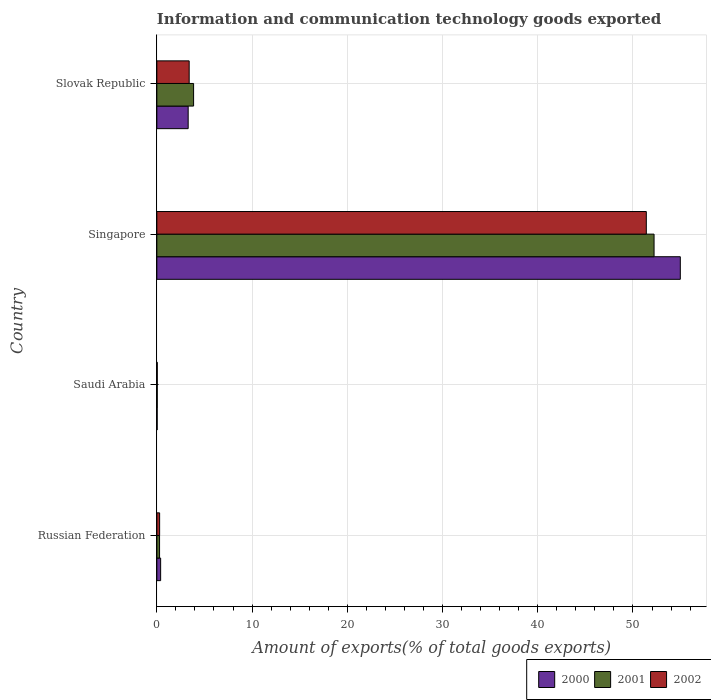How many groups of bars are there?
Give a very brief answer. 4. Are the number of bars per tick equal to the number of legend labels?
Offer a terse response. Yes. How many bars are there on the 1st tick from the top?
Your response must be concise. 3. How many bars are there on the 4th tick from the bottom?
Your response must be concise. 3. What is the label of the 1st group of bars from the top?
Give a very brief answer. Slovak Republic. In how many cases, is the number of bars for a given country not equal to the number of legend labels?
Offer a terse response. 0. What is the amount of goods exported in 2002 in Saudi Arabia?
Offer a terse response. 0.04. Across all countries, what is the maximum amount of goods exported in 2001?
Offer a very short reply. 52.22. Across all countries, what is the minimum amount of goods exported in 2001?
Keep it short and to the point. 0.04. In which country was the amount of goods exported in 2000 maximum?
Your answer should be compact. Singapore. In which country was the amount of goods exported in 2001 minimum?
Provide a short and direct response. Saudi Arabia. What is the total amount of goods exported in 2001 in the graph?
Offer a very short reply. 56.4. What is the difference between the amount of goods exported in 2001 in Russian Federation and that in Singapore?
Your answer should be very brief. -51.93. What is the difference between the amount of goods exported in 2001 in Slovak Republic and the amount of goods exported in 2002 in Singapore?
Give a very brief answer. -47.54. What is the average amount of goods exported in 2002 per country?
Ensure brevity in your answer.  13.78. What is the difference between the amount of goods exported in 2000 and amount of goods exported in 2002 in Slovak Republic?
Provide a short and direct response. -0.11. What is the ratio of the amount of goods exported in 2000 in Singapore to that in Slovak Republic?
Keep it short and to the point. 16.71. What is the difference between the highest and the second highest amount of goods exported in 2002?
Your response must be concise. 48.01. What is the difference between the highest and the lowest amount of goods exported in 2001?
Keep it short and to the point. 52.17. What does the 2nd bar from the top in Slovak Republic represents?
Offer a very short reply. 2001. What does the 2nd bar from the bottom in Saudi Arabia represents?
Give a very brief answer. 2001. Is it the case that in every country, the sum of the amount of goods exported in 2000 and amount of goods exported in 2002 is greater than the amount of goods exported in 2001?
Ensure brevity in your answer.  Yes. How many bars are there?
Keep it short and to the point. 12. Are all the bars in the graph horizontal?
Your answer should be compact. Yes. What is the difference between two consecutive major ticks on the X-axis?
Ensure brevity in your answer.  10. Does the graph contain any zero values?
Make the answer very short. No. Does the graph contain grids?
Make the answer very short. Yes. Where does the legend appear in the graph?
Make the answer very short. Bottom right. How many legend labels are there?
Offer a terse response. 3. What is the title of the graph?
Your answer should be very brief. Information and communication technology goods exported. What is the label or title of the X-axis?
Your answer should be very brief. Amount of exports(% of total goods exports). What is the label or title of the Y-axis?
Offer a very short reply. Country. What is the Amount of exports(% of total goods exports) in 2000 in Russian Federation?
Provide a succinct answer. 0.4. What is the Amount of exports(% of total goods exports) in 2001 in Russian Federation?
Your answer should be very brief. 0.28. What is the Amount of exports(% of total goods exports) of 2002 in Russian Federation?
Keep it short and to the point. 0.29. What is the Amount of exports(% of total goods exports) in 2000 in Saudi Arabia?
Provide a succinct answer. 0.03. What is the Amount of exports(% of total goods exports) in 2001 in Saudi Arabia?
Your response must be concise. 0.04. What is the Amount of exports(% of total goods exports) in 2002 in Saudi Arabia?
Give a very brief answer. 0.04. What is the Amount of exports(% of total goods exports) in 2000 in Singapore?
Keep it short and to the point. 54.97. What is the Amount of exports(% of total goods exports) in 2001 in Singapore?
Keep it short and to the point. 52.22. What is the Amount of exports(% of total goods exports) in 2002 in Singapore?
Ensure brevity in your answer.  51.4. What is the Amount of exports(% of total goods exports) in 2000 in Slovak Republic?
Your response must be concise. 3.29. What is the Amount of exports(% of total goods exports) of 2001 in Slovak Republic?
Provide a succinct answer. 3.86. What is the Amount of exports(% of total goods exports) in 2002 in Slovak Republic?
Provide a succinct answer. 3.4. Across all countries, what is the maximum Amount of exports(% of total goods exports) of 2000?
Offer a terse response. 54.97. Across all countries, what is the maximum Amount of exports(% of total goods exports) of 2001?
Provide a succinct answer. 52.22. Across all countries, what is the maximum Amount of exports(% of total goods exports) in 2002?
Your response must be concise. 51.4. Across all countries, what is the minimum Amount of exports(% of total goods exports) in 2000?
Offer a terse response. 0.03. Across all countries, what is the minimum Amount of exports(% of total goods exports) in 2001?
Your answer should be very brief. 0.04. Across all countries, what is the minimum Amount of exports(% of total goods exports) of 2002?
Keep it short and to the point. 0.04. What is the total Amount of exports(% of total goods exports) in 2000 in the graph?
Your response must be concise. 58.7. What is the total Amount of exports(% of total goods exports) in 2001 in the graph?
Your answer should be very brief. 56.4. What is the total Amount of exports(% of total goods exports) of 2002 in the graph?
Your answer should be very brief. 55.13. What is the difference between the Amount of exports(% of total goods exports) in 2000 in Russian Federation and that in Saudi Arabia?
Provide a succinct answer. 0.37. What is the difference between the Amount of exports(% of total goods exports) in 2001 in Russian Federation and that in Saudi Arabia?
Your response must be concise. 0.24. What is the difference between the Amount of exports(% of total goods exports) of 2002 in Russian Federation and that in Saudi Arabia?
Give a very brief answer. 0.25. What is the difference between the Amount of exports(% of total goods exports) in 2000 in Russian Federation and that in Singapore?
Make the answer very short. -54.58. What is the difference between the Amount of exports(% of total goods exports) of 2001 in Russian Federation and that in Singapore?
Keep it short and to the point. -51.93. What is the difference between the Amount of exports(% of total goods exports) in 2002 in Russian Federation and that in Singapore?
Offer a very short reply. -51.11. What is the difference between the Amount of exports(% of total goods exports) in 2000 in Russian Federation and that in Slovak Republic?
Your answer should be very brief. -2.89. What is the difference between the Amount of exports(% of total goods exports) of 2001 in Russian Federation and that in Slovak Republic?
Provide a short and direct response. -3.57. What is the difference between the Amount of exports(% of total goods exports) in 2002 in Russian Federation and that in Slovak Republic?
Offer a terse response. -3.1. What is the difference between the Amount of exports(% of total goods exports) in 2000 in Saudi Arabia and that in Singapore?
Provide a succinct answer. -54.94. What is the difference between the Amount of exports(% of total goods exports) in 2001 in Saudi Arabia and that in Singapore?
Your answer should be very brief. -52.17. What is the difference between the Amount of exports(% of total goods exports) in 2002 in Saudi Arabia and that in Singapore?
Your answer should be very brief. -51.36. What is the difference between the Amount of exports(% of total goods exports) of 2000 in Saudi Arabia and that in Slovak Republic?
Provide a short and direct response. -3.26. What is the difference between the Amount of exports(% of total goods exports) of 2001 in Saudi Arabia and that in Slovak Republic?
Offer a terse response. -3.82. What is the difference between the Amount of exports(% of total goods exports) in 2002 in Saudi Arabia and that in Slovak Republic?
Offer a very short reply. -3.35. What is the difference between the Amount of exports(% of total goods exports) in 2000 in Singapore and that in Slovak Republic?
Provide a succinct answer. 51.69. What is the difference between the Amount of exports(% of total goods exports) in 2001 in Singapore and that in Slovak Republic?
Your response must be concise. 48.36. What is the difference between the Amount of exports(% of total goods exports) of 2002 in Singapore and that in Slovak Republic?
Your response must be concise. 48.01. What is the difference between the Amount of exports(% of total goods exports) in 2000 in Russian Federation and the Amount of exports(% of total goods exports) in 2001 in Saudi Arabia?
Make the answer very short. 0.36. What is the difference between the Amount of exports(% of total goods exports) in 2000 in Russian Federation and the Amount of exports(% of total goods exports) in 2002 in Saudi Arabia?
Provide a succinct answer. 0.35. What is the difference between the Amount of exports(% of total goods exports) in 2001 in Russian Federation and the Amount of exports(% of total goods exports) in 2002 in Saudi Arabia?
Offer a very short reply. 0.24. What is the difference between the Amount of exports(% of total goods exports) in 2000 in Russian Federation and the Amount of exports(% of total goods exports) in 2001 in Singapore?
Offer a terse response. -51.82. What is the difference between the Amount of exports(% of total goods exports) in 2000 in Russian Federation and the Amount of exports(% of total goods exports) in 2002 in Singapore?
Keep it short and to the point. -51. What is the difference between the Amount of exports(% of total goods exports) of 2001 in Russian Federation and the Amount of exports(% of total goods exports) of 2002 in Singapore?
Your answer should be compact. -51.12. What is the difference between the Amount of exports(% of total goods exports) of 2000 in Russian Federation and the Amount of exports(% of total goods exports) of 2001 in Slovak Republic?
Your answer should be compact. -3.46. What is the difference between the Amount of exports(% of total goods exports) of 2000 in Russian Federation and the Amount of exports(% of total goods exports) of 2002 in Slovak Republic?
Keep it short and to the point. -3. What is the difference between the Amount of exports(% of total goods exports) of 2001 in Russian Federation and the Amount of exports(% of total goods exports) of 2002 in Slovak Republic?
Give a very brief answer. -3.11. What is the difference between the Amount of exports(% of total goods exports) in 2000 in Saudi Arabia and the Amount of exports(% of total goods exports) in 2001 in Singapore?
Your answer should be compact. -52.18. What is the difference between the Amount of exports(% of total goods exports) of 2000 in Saudi Arabia and the Amount of exports(% of total goods exports) of 2002 in Singapore?
Your answer should be very brief. -51.37. What is the difference between the Amount of exports(% of total goods exports) of 2001 in Saudi Arabia and the Amount of exports(% of total goods exports) of 2002 in Singapore?
Make the answer very short. -51.36. What is the difference between the Amount of exports(% of total goods exports) in 2000 in Saudi Arabia and the Amount of exports(% of total goods exports) in 2001 in Slovak Republic?
Ensure brevity in your answer.  -3.83. What is the difference between the Amount of exports(% of total goods exports) in 2000 in Saudi Arabia and the Amount of exports(% of total goods exports) in 2002 in Slovak Republic?
Ensure brevity in your answer.  -3.36. What is the difference between the Amount of exports(% of total goods exports) of 2001 in Saudi Arabia and the Amount of exports(% of total goods exports) of 2002 in Slovak Republic?
Offer a very short reply. -3.35. What is the difference between the Amount of exports(% of total goods exports) in 2000 in Singapore and the Amount of exports(% of total goods exports) in 2001 in Slovak Republic?
Provide a short and direct response. 51.12. What is the difference between the Amount of exports(% of total goods exports) in 2000 in Singapore and the Amount of exports(% of total goods exports) in 2002 in Slovak Republic?
Your response must be concise. 51.58. What is the difference between the Amount of exports(% of total goods exports) in 2001 in Singapore and the Amount of exports(% of total goods exports) in 2002 in Slovak Republic?
Your answer should be compact. 48.82. What is the average Amount of exports(% of total goods exports) of 2000 per country?
Give a very brief answer. 14.67. What is the average Amount of exports(% of total goods exports) of 2001 per country?
Provide a succinct answer. 14.1. What is the average Amount of exports(% of total goods exports) of 2002 per country?
Your response must be concise. 13.78. What is the difference between the Amount of exports(% of total goods exports) in 2000 and Amount of exports(% of total goods exports) in 2001 in Russian Federation?
Make the answer very short. 0.11. What is the difference between the Amount of exports(% of total goods exports) in 2000 and Amount of exports(% of total goods exports) in 2002 in Russian Federation?
Keep it short and to the point. 0.11. What is the difference between the Amount of exports(% of total goods exports) in 2001 and Amount of exports(% of total goods exports) in 2002 in Russian Federation?
Your response must be concise. -0.01. What is the difference between the Amount of exports(% of total goods exports) in 2000 and Amount of exports(% of total goods exports) in 2001 in Saudi Arabia?
Offer a terse response. -0.01. What is the difference between the Amount of exports(% of total goods exports) in 2000 and Amount of exports(% of total goods exports) in 2002 in Saudi Arabia?
Offer a terse response. -0.01. What is the difference between the Amount of exports(% of total goods exports) in 2001 and Amount of exports(% of total goods exports) in 2002 in Saudi Arabia?
Provide a succinct answer. -0. What is the difference between the Amount of exports(% of total goods exports) of 2000 and Amount of exports(% of total goods exports) of 2001 in Singapore?
Provide a short and direct response. 2.76. What is the difference between the Amount of exports(% of total goods exports) of 2000 and Amount of exports(% of total goods exports) of 2002 in Singapore?
Give a very brief answer. 3.57. What is the difference between the Amount of exports(% of total goods exports) in 2001 and Amount of exports(% of total goods exports) in 2002 in Singapore?
Your answer should be very brief. 0.81. What is the difference between the Amount of exports(% of total goods exports) of 2000 and Amount of exports(% of total goods exports) of 2001 in Slovak Republic?
Your answer should be very brief. -0.57. What is the difference between the Amount of exports(% of total goods exports) of 2000 and Amount of exports(% of total goods exports) of 2002 in Slovak Republic?
Your answer should be very brief. -0.11. What is the difference between the Amount of exports(% of total goods exports) of 2001 and Amount of exports(% of total goods exports) of 2002 in Slovak Republic?
Make the answer very short. 0.46. What is the ratio of the Amount of exports(% of total goods exports) in 2000 in Russian Federation to that in Saudi Arabia?
Your answer should be very brief. 11.9. What is the ratio of the Amount of exports(% of total goods exports) in 2001 in Russian Federation to that in Saudi Arabia?
Provide a succinct answer. 6.65. What is the ratio of the Amount of exports(% of total goods exports) of 2002 in Russian Federation to that in Saudi Arabia?
Give a very brief answer. 6.61. What is the ratio of the Amount of exports(% of total goods exports) of 2000 in Russian Federation to that in Singapore?
Provide a succinct answer. 0.01. What is the ratio of the Amount of exports(% of total goods exports) in 2001 in Russian Federation to that in Singapore?
Offer a terse response. 0.01. What is the ratio of the Amount of exports(% of total goods exports) in 2002 in Russian Federation to that in Singapore?
Provide a short and direct response. 0.01. What is the ratio of the Amount of exports(% of total goods exports) in 2000 in Russian Federation to that in Slovak Republic?
Keep it short and to the point. 0.12. What is the ratio of the Amount of exports(% of total goods exports) in 2001 in Russian Federation to that in Slovak Republic?
Provide a succinct answer. 0.07. What is the ratio of the Amount of exports(% of total goods exports) in 2002 in Russian Federation to that in Slovak Republic?
Offer a very short reply. 0.09. What is the ratio of the Amount of exports(% of total goods exports) in 2000 in Saudi Arabia to that in Singapore?
Offer a terse response. 0. What is the ratio of the Amount of exports(% of total goods exports) of 2001 in Saudi Arabia to that in Singapore?
Provide a succinct answer. 0. What is the ratio of the Amount of exports(% of total goods exports) in 2002 in Saudi Arabia to that in Singapore?
Make the answer very short. 0. What is the ratio of the Amount of exports(% of total goods exports) of 2000 in Saudi Arabia to that in Slovak Republic?
Keep it short and to the point. 0.01. What is the ratio of the Amount of exports(% of total goods exports) of 2001 in Saudi Arabia to that in Slovak Republic?
Your answer should be very brief. 0.01. What is the ratio of the Amount of exports(% of total goods exports) in 2002 in Saudi Arabia to that in Slovak Republic?
Your answer should be very brief. 0.01. What is the ratio of the Amount of exports(% of total goods exports) in 2000 in Singapore to that in Slovak Republic?
Your answer should be compact. 16.71. What is the ratio of the Amount of exports(% of total goods exports) of 2001 in Singapore to that in Slovak Republic?
Offer a very short reply. 13.53. What is the ratio of the Amount of exports(% of total goods exports) of 2002 in Singapore to that in Slovak Republic?
Your answer should be very brief. 15.14. What is the difference between the highest and the second highest Amount of exports(% of total goods exports) of 2000?
Make the answer very short. 51.69. What is the difference between the highest and the second highest Amount of exports(% of total goods exports) of 2001?
Offer a very short reply. 48.36. What is the difference between the highest and the second highest Amount of exports(% of total goods exports) in 2002?
Your answer should be very brief. 48.01. What is the difference between the highest and the lowest Amount of exports(% of total goods exports) in 2000?
Offer a very short reply. 54.94. What is the difference between the highest and the lowest Amount of exports(% of total goods exports) of 2001?
Give a very brief answer. 52.17. What is the difference between the highest and the lowest Amount of exports(% of total goods exports) of 2002?
Provide a succinct answer. 51.36. 